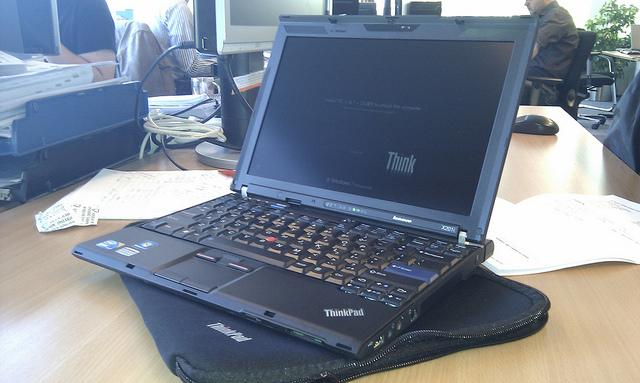What state is the computer most likely in? Please explain your reasoning. starting up. The computer is likely starting up since it's giving the loading message. 